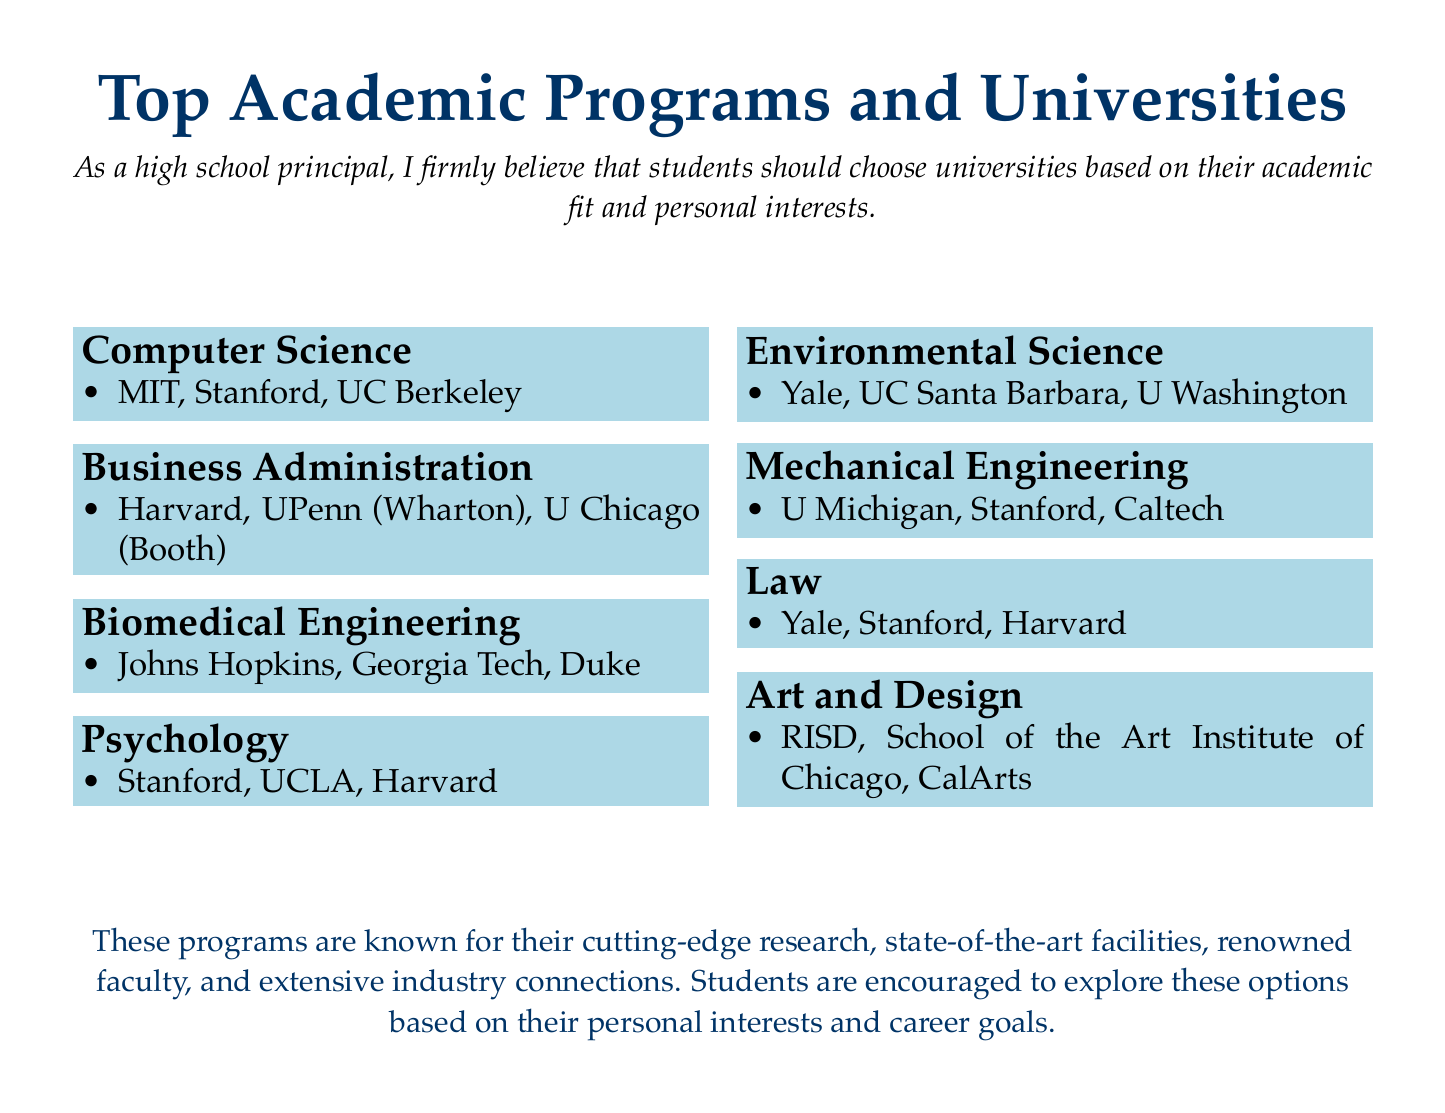What are the top three universities for Computer Science? The document lists MIT, Stanford, and UC Berkeley as the top universities for Computer Science.
Answer: MIT, Stanford, UC Berkeley Which program is associated with Harvard? Harvard is listed under Business Administration, Law, and Psychology in the document, but the asked program is Business Administration.
Answer: Business Administration How many universities are listed for Biomedical Engineering? The document mentions three universities for Biomedical Engineering: Johns Hopkins, Georgia Tech, and Duke.
Answer: Three What colors are used in the document's title? The title uses dark blue for the text color and light blue for the background color of the program sections.
Answer: Dark blue, light blue Name one university from the Environmental Science program. The document includes Yale, UC Santa Barbara, and University of Washington as top universities for Environmental Science.
Answer: Yale Which program has the highest number of listed universities? Each program in the document has exactly three universities listed; therefore, there is no program with a higher amount.
Answer: None What is emphasized as important for choosing a university? The document emphasizes that students should choose universities based on their academic fit and personal interests.
Answer: Academic fit and personal interests Which program is associated with the School of the Art Institute of Chicago? The document states that the School of the Art Institute of Chicago is associated with the Art and Design program.
Answer: Art and Design How many academic programs are listed in the document? The document lists a total of eight academic programs.
Answer: Eight 